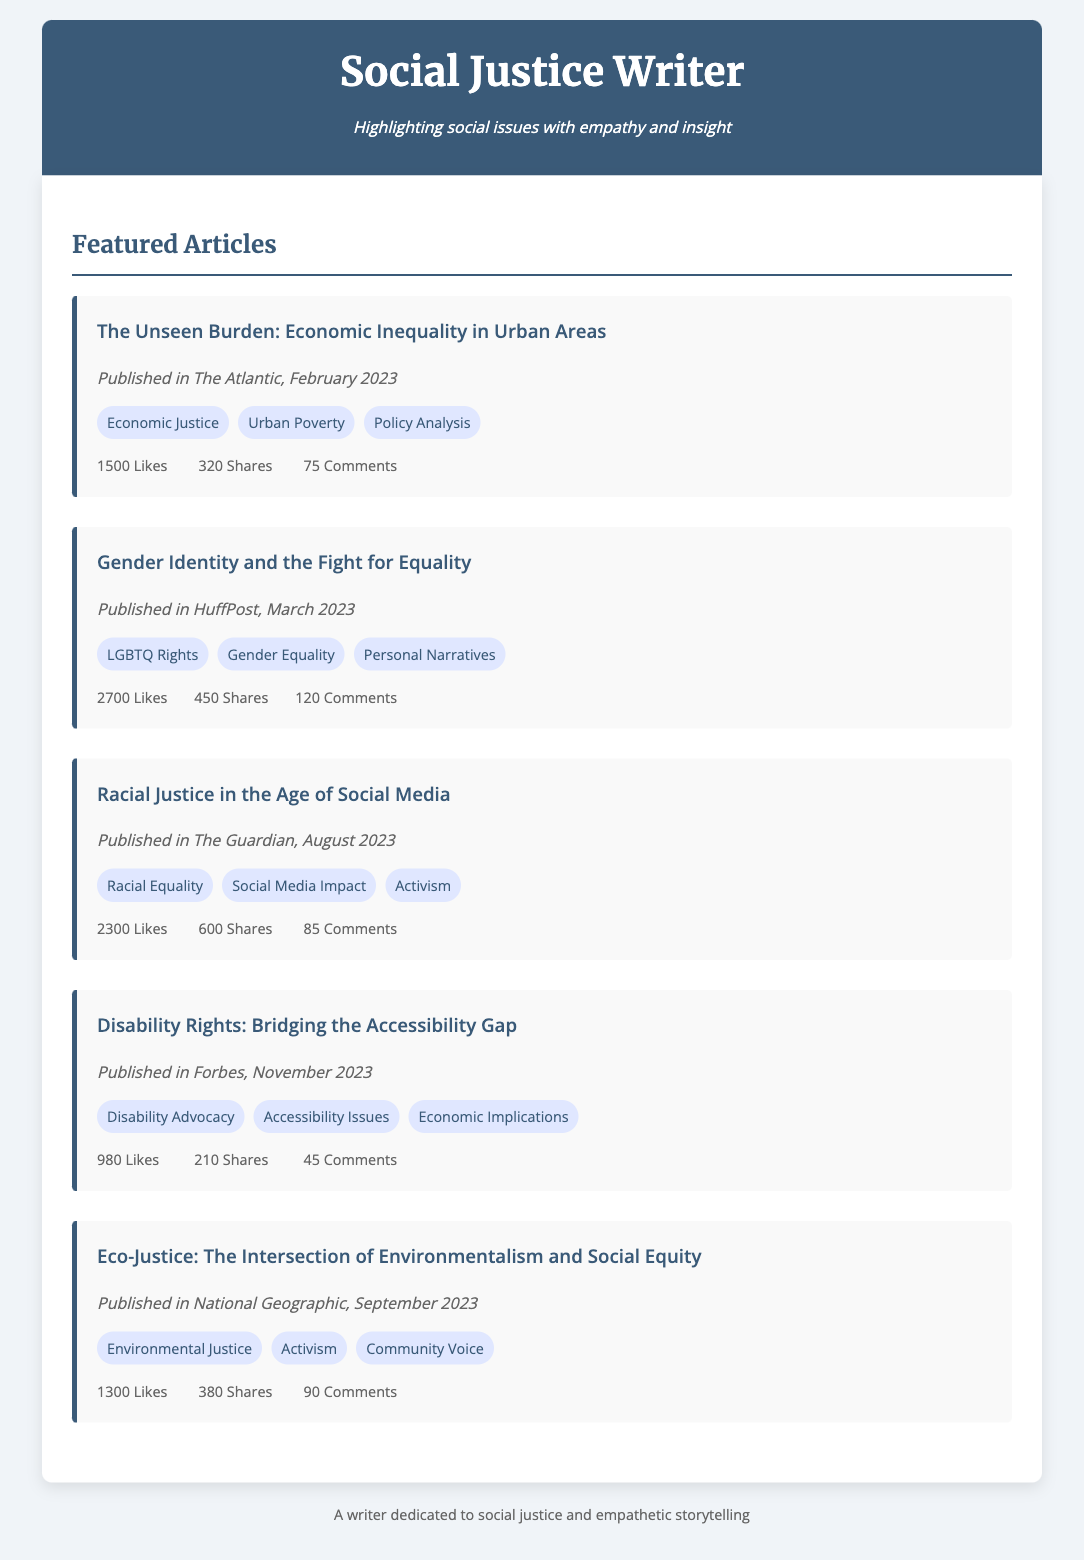What is the title of the first article? The title of the first article is listed prominently in the document, allowing easy identification.
Answer: The Unseen Burden: Economic Inequality in Urban Areas Which publication featured the article on Gender Identity? The document specifies the publications for each article, making it clear where they were published.
Answer: HuffPost How many likes did the article about Racial Justice receive? The engagement statistics for each article are clearly stated, including the number of likes.
Answer: 2300 Likes When was the article on Disability Rights published? The publication date is provided for each article, which helps identify when it was released.
Answer: November 2023 What theme is addressed in the article about Eco-Justice? Each article has several associated themes listed, indicating the topics discussed within them.
Answer: Environmental Justice Which article had the highest number of shares? By comparing the shares of each article mentioned in the engagement section, one can determine which article was most shared.
Answer: Gender Identity and the Fight for Equality What is a common theme among the articles? The document shows the themes for each article, making it possible to identify shared topics across them.
Answer: Activism How many comments did the article in The Atlantic receive? The engagement section includes the total number of comments for each article, which can be easily extracted.
Answer: 75 Comments What is the overarching role of the writer as indicated in the footer? The footer provides a summary of the writer's purpose and approach to social issues, reflecting their focus.
Answer: A writer dedicated to social justice and empathetic storytelling 